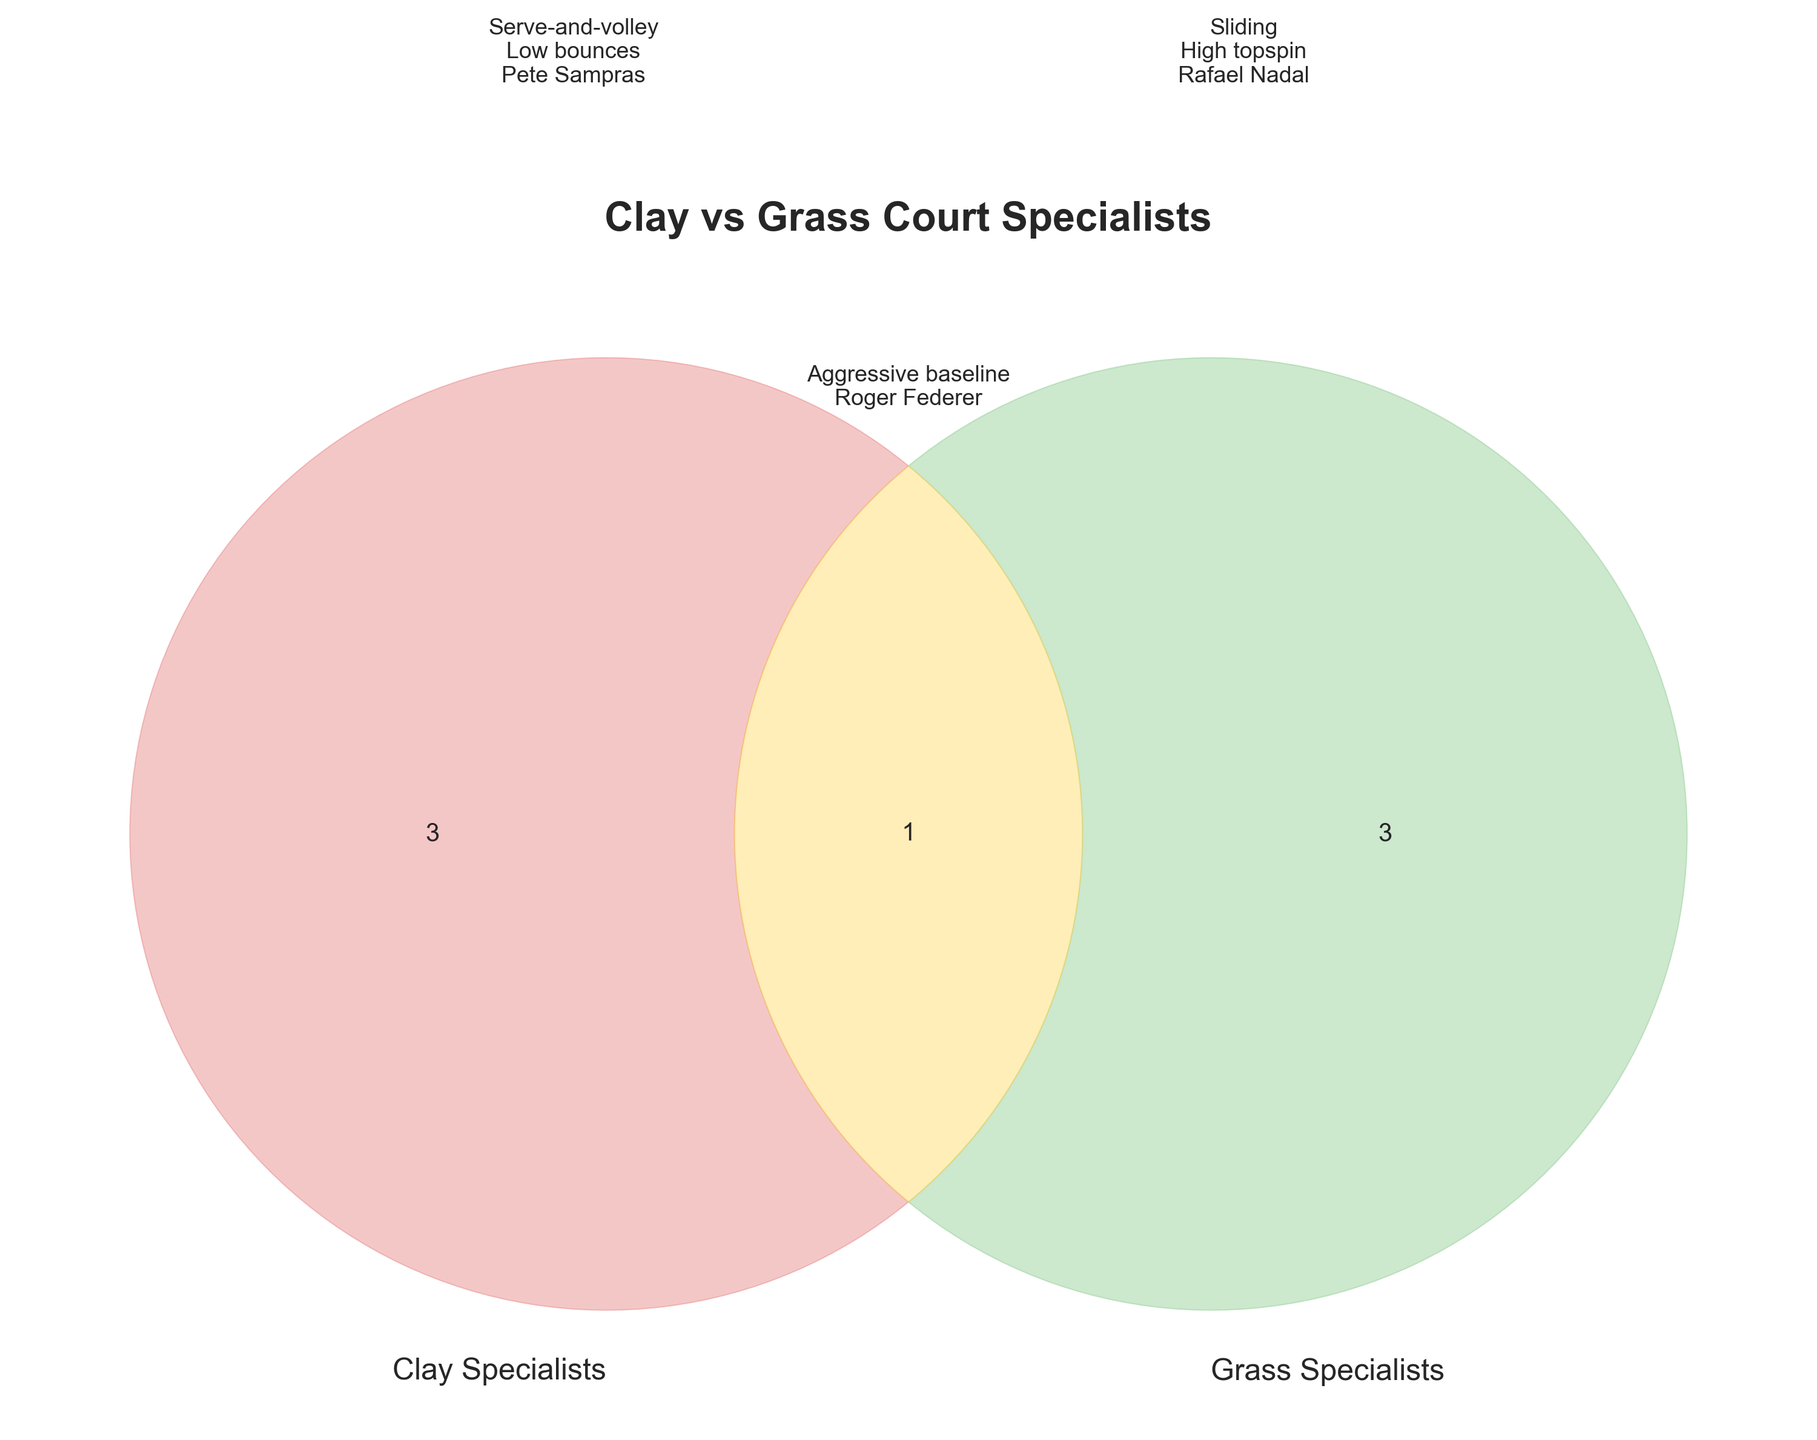What is the title of the figure? The title can be found at the top of the figure, usually in a larger or bold font.
Answer: Clay vs Grass Court Specialists How many sets are compared in the Venn Diagram? A Venn Diagram compares different groups, and the sets are represented by circles. Count the circles in the diagram.
Answer: 2 Which section of the Venn Diagram includes aggressive baseline play? Look for the text label representing "Aggressive baseline play" and identify which part of the Venn Diagram it is placed in.
Answer: Both Who is a well-known player listed under clay specialists? Check the text within the circle labeled "Clay Specialists" to find notable names.
Answer: Rafael Nadal Which group is depicted using green color in their section? Observe the color used for each section and identify which one is green.
Answer: Grass Specialists Which tournaments do both clay and grass court specialists play? Look in the overlapping section of the Venn Diagram for the list of tournaments.
Answer: Australian Open Are longer rallies associated with clay or grass court specialists? Check the labeled attributes in the Clay Specialists' section for "Longer rallies".
Answer: Clay Which type of footwear is common for players who specialize on both types of courts? Look in the overlapping section for the label regarding footwear.
Answer: All-court footwear What is the main playing style of grass specialists? Check the main label for the Grass Specialists' section regarding playing style.
Answer: Serve-and-volley What unique attribute is associated with Rafael Nadal's style? Look for the attributes listed under "Clay Specialists" and identify the one uniquely related to Rafael Nadal.
Answer: Sliding 